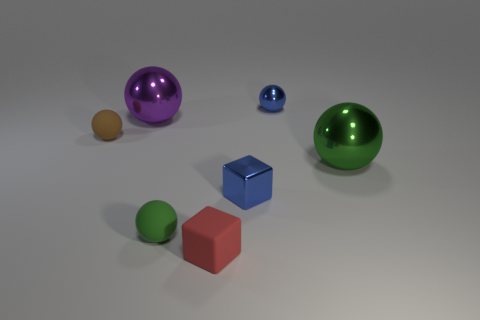Subtract all blue balls. How many balls are left? 4 Subtract all brown matte balls. How many balls are left? 4 Subtract all yellow spheres. Subtract all blue cylinders. How many spheres are left? 5 Add 2 tiny blue metal balls. How many objects exist? 9 Subtract all spheres. How many objects are left? 2 Add 6 brown matte things. How many brown matte things are left? 7 Add 7 big brown shiny blocks. How many big brown shiny blocks exist? 7 Subtract 1 brown spheres. How many objects are left? 6 Subtract all green things. Subtract all tiny metal objects. How many objects are left? 3 